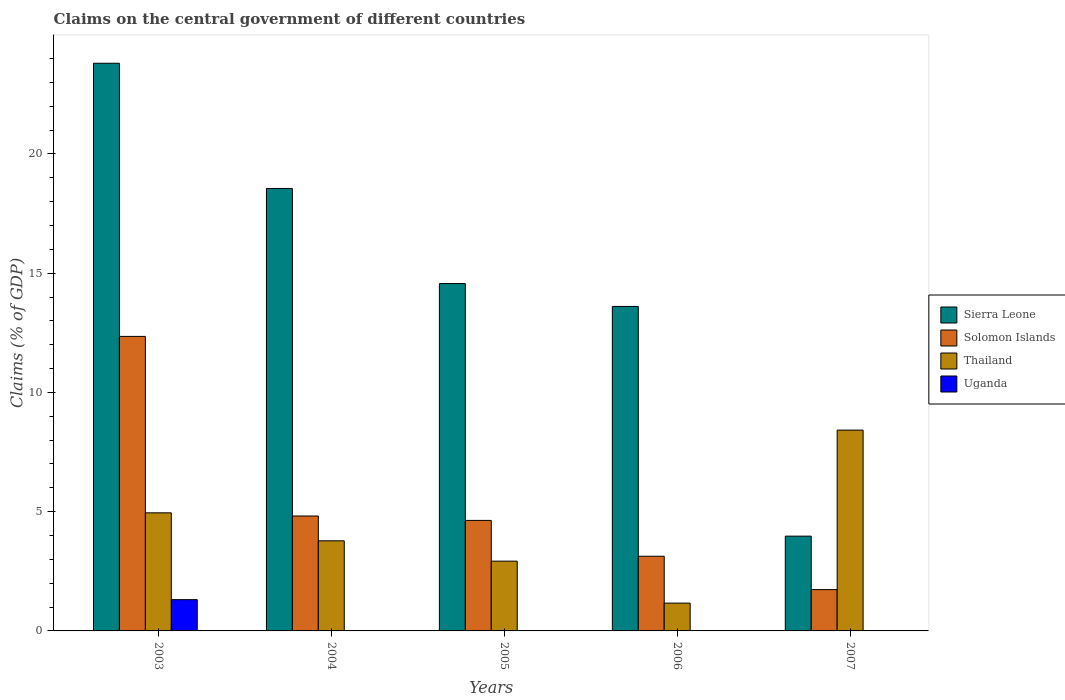Are the number of bars per tick equal to the number of legend labels?
Make the answer very short. No. Are the number of bars on each tick of the X-axis equal?
Offer a very short reply. No. How many bars are there on the 5th tick from the left?
Your answer should be compact. 3. What is the label of the 3rd group of bars from the left?
Your response must be concise. 2005. What is the percentage of GDP claimed on the central government in Sierra Leone in 2006?
Your answer should be very brief. 13.6. Across all years, what is the maximum percentage of GDP claimed on the central government in Uganda?
Offer a very short reply. 1.31. Across all years, what is the minimum percentage of GDP claimed on the central government in Thailand?
Offer a terse response. 1.17. In which year was the percentage of GDP claimed on the central government in Thailand maximum?
Offer a very short reply. 2007. What is the total percentage of GDP claimed on the central government in Uganda in the graph?
Offer a very short reply. 1.31. What is the difference between the percentage of GDP claimed on the central government in Sierra Leone in 2003 and that in 2007?
Your response must be concise. 19.83. What is the difference between the percentage of GDP claimed on the central government in Thailand in 2007 and the percentage of GDP claimed on the central government in Solomon Islands in 2003?
Give a very brief answer. -3.93. What is the average percentage of GDP claimed on the central government in Sierra Leone per year?
Your response must be concise. 14.9. In the year 2006, what is the difference between the percentage of GDP claimed on the central government in Sierra Leone and percentage of GDP claimed on the central government in Solomon Islands?
Give a very brief answer. 10.47. In how many years, is the percentage of GDP claimed on the central government in Solomon Islands greater than 10 %?
Offer a very short reply. 1. What is the ratio of the percentage of GDP claimed on the central government in Solomon Islands in 2003 to that in 2004?
Make the answer very short. 2.56. Is the percentage of GDP claimed on the central government in Thailand in 2003 less than that in 2006?
Offer a very short reply. No. Is the difference between the percentage of GDP claimed on the central government in Sierra Leone in 2005 and 2006 greater than the difference between the percentage of GDP claimed on the central government in Solomon Islands in 2005 and 2006?
Offer a terse response. No. What is the difference between the highest and the second highest percentage of GDP claimed on the central government in Thailand?
Offer a very short reply. 3.47. What is the difference between the highest and the lowest percentage of GDP claimed on the central government in Sierra Leone?
Your answer should be very brief. 19.83. In how many years, is the percentage of GDP claimed on the central government in Uganda greater than the average percentage of GDP claimed on the central government in Uganda taken over all years?
Your answer should be very brief. 1. Is it the case that in every year, the sum of the percentage of GDP claimed on the central government in Uganda and percentage of GDP claimed on the central government in Solomon Islands is greater than the sum of percentage of GDP claimed on the central government in Sierra Leone and percentage of GDP claimed on the central government in Thailand?
Offer a very short reply. No. How many bars are there?
Your response must be concise. 16. How many years are there in the graph?
Give a very brief answer. 5. What is the difference between two consecutive major ticks on the Y-axis?
Keep it short and to the point. 5. Does the graph contain any zero values?
Ensure brevity in your answer.  Yes. What is the title of the graph?
Your answer should be compact. Claims on the central government of different countries. Does "Papua New Guinea" appear as one of the legend labels in the graph?
Your answer should be compact. No. What is the label or title of the X-axis?
Give a very brief answer. Years. What is the label or title of the Y-axis?
Your answer should be compact. Claims (% of GDP). What is the Claims (% of GDP) in Sierra Leone in 2003?
Ensure brevity in your answer.  23.8. What is the Claims (% of GDP) of Solomon Islands in 2003?
Offer a very short reply. 12.35. What is the Claims (% of GDP) of Thailand in 2003?
Your answer should be very brief. 4.95. What is the Claims (% of GDP) of Uganda in 2003?
Keep it short and to the point. 1.31. What is the Claims (% of GDP) in Sierra Leone in 2004?
Provide a short and direct response. 18.55. What is the Claims (% of GDP) in Solomon Islands in 2004?
Provide a short and direct response. 4.82. What is the Claims (% of GDP) in Thailand in 2004?
Provide a short and direct response. 3.78. What is the Claims (% of GDP) in Sierra Leone in 2005?
Keep it short and to the point. 14.56. What is the Claims (% of GDP) of Solomon Islands in 2005?
Offer a terse response. 4.63. What is the Claims (% of GDP) of Thailand in 2005?
Make the answer very short. 2.93. What is the Claims (% of GDP) of Uganda in 2005?
Your response must be concise. 0. What is the Claims (% of GDP) in Sierra Leone in 2006?
Your answer should be very brief. 13.6. What is the Claims (% of GDP) of Solomon Islands in 2006?
Ensure brevity in your answer.  3.13. What is the Claims (% of GDP) of Thailand in 2006?
Your answer should be compact. 1.17. What is the Claims (% of GDP) in Sierra Leone in 2007?
Offer a terse response. 3.97. What is the Claims (% of GDP) in Solomon Islands in 2007?
Your response must be concise. 1.73. What is the Claims (% of GDP) of Thailand in 2007?
Provide a succinct answer. 8.42. Across all years, what is the maximum Claims (% of GDP) in Sierra Leone?
Offer a very short reply. 23.8. Across all years, what is the maximum Claims (% of GDP) of Solomon Islands?
Provide a short and direct response. 12.35. Across all years, what is the maximum Claims (% of GDP) of Thailand?
Your answer should be very brief. 8.42. Across all years, what is the maximum Claims (% of GDP) of Uganda?
Provide a short and direct response. 1.31. Across all years, what is the minimum Claims (% of GDP) of Sierra Leone?
Ensure brevity in your answer.  3.97. Across all years, what is the minimum Claims (% of GDP) in Solomon Islands?
Provide a short and direct response. 1.73. Across all years, what is the minimum Claims (% of GDP) of Thailand?
Offer a terse response. 1.17. Across all years, what is the minimum Claims (% of GDP) in Uganda?
Your answer should be compact. 0. What is the total Claims (% of GDP) of Sierra Leone in the graph?
Ensure brevity in your answer.  74.49. What is the total Claims (% of GDP) of Solomon Islands in the graph?
Your answer should be very brief. 26.66. What is the total Claims (% of GDP) of Thailand in the graph?
Give a very brief answer. 21.24. What is the total Claims (% of GDP) of Uganda in the graph?
Offer a very short reply. 1.31. What is the difference between the Claims (% of GDP) of Sierra Leone in 2003 and that in 2004?
Offer a very short reply. 5.25. What is the difference between the Claims (% of GDP) of Solomon Islands in 2003 and that in 2004?
Provide a short and direct response. 7.53. What is the difference between the Claims (% of GDP) in Thailand in 2003 and that in 2004?
Offer a very short reply. 1.17. What is the difference between the Claims (% of GDP) in Sierra Leone in 2003 and that in 2005?
Keep it short and to the point. 9.24. What is the difference between the Claims (% of GDP) in Solomon Islands in 2003 and that in 2005?
Your answer should be very brief. 7.72. What is the difference between the Claims (% of GDP) of Thailand in 2003 and that in 2005?
Provide a short and direct response. 2.03. What is the difference between the Claims (% of GDP) of Sierra Leone in 2003 and that in 2006?
Ensure brevity in your answer.  10.2. What is the difference between the Claims (% of GDP) in Solomon Islands in 2003 and that in 2006?
Offer a terse response. 9.22. What is the difference between the Claims (% of GDP) of Thailand in 2003 and that in 2006?
Offer a very short reply. 3.79. What is the difference between the Claims (% of GDP) of Sierra Leone in 2003 and that in 2007?
Keep it short and to the point. 19.83. What is the difference between the Claims (% of GDP) in Solomon Islands in 2003 and that in 2007?
Your answer should be compact. 10.62. What is the difference between the Claims (% of GDP) in Thailand in 2003 and that in 2007?
Your answer should be very brief. -3.47. What is the difference between the Claims (% of GDP) of Sierra Leone in 2004 and that in 2005?
Your answer should be very brief. 3.99. What is the difference between the Claims (% of GDP) in Solomon Islands in 2004 and that in 2005?
Provide a succinct answer. 0.18. What is the difference between the Claims (% of GDP) in Thailand in 2004 and that in 2005?
Ensure brevity in your answer.  0.85. What is the difference between the Claims (% of GDP) in Sierra Leone in 2004 and that in 2006?
Make the answer very short. 4.95. What is the difference between the Claims (% of GDP) in Solomon Islands in 2004 and that in 2006?
Offer a terse response. 1.69. What is the difference between the Claims (% of GDP) in Thailand in 2004 and that in 2006?
Your answer should be compact. 2.61. What is the difference between the Claims (% of GDP) of Sierra Leone in 2004 and that in 2007?
Offer a very short reply. 14.58. What is the difference between the Claims (% of GDP) in Solomon Islands in 2004 and that in 2007?
Ensure brevity in your answer.  3.09. What is the difference between the Claims (% of GDP) of Thailand in 2004 and that in 2007?
Make the answer very short. -4.64. What is the difference between the Claims (% of GDP) of Sierra Leone in 2005 and that in 2006?
Your answer should be very brief. 0.96. What is the difference between the Claims (% of GDP) of Solomon Islands in 2005 and that in 2006?
Provide a succinct answer. 1.5. What is the difference between the Claims (% of GDP) of Thailand in 2005 and that in 2006?
Offer a terse response. 1.76. What is the difference between the Claims (% of GDP) in Sierra Leone in 2005 and that in 2007?
Keep it short and to the point. 10.59. What is the difference between the Claims (% of GDP) in Solomon Islands in 2005 and that in 2007?
Your answer should be very brief. 2.9. What is the difference between the Claims (% of GDP) in Thailand in 2005 and that in 2007?
Your response must be concise. -5.49. What is the difference between the Claims (% of GDP) of Sierra Leone in 2006 and that in 2007?
Your response must be concise. 9.63. What is the difference between the Claims (% of GDP) in Solomon Islands in 2006 and that in 2007?
Make the answer very short. 1.4. What is the difference between the Claims (% of GDP) in Thailand in 2006 and that in 2007?
Your answer should be very brief. -7.25. What is the difference between the Claims (% of GDP) in Sierra Leone in 2003 and the Claims (% of GDP) in Solomon Islands in 2004?
Give a very brief answer. 18.98. What is the difference between the Claims (% of GDP) of Sierra Leone in 2003 and the Claims (% of GDP) of Thailand in 2004?
Provide a succinct answer. 20.02. What is the difference between the Claims (% of GDP) of Solomon Islands in 2003 and the Claims (% of GDP) of Thailand in 2004?
Ensure brevity in your answer.  8.57. What is the difference between the Claims (% of GDP) in Sierra Leone in 2003 and the Claims (% of GDP) in Solomon Islands in 2005?
Provide a succinct answer. 19.17. What is the difference between the Claims (% of GDP) in Sierra Leone in 2003 and the Claims (% of GDP) in Thailand in 2005?
Offer a terse response. 20.87. What is the difference between the Claims (% of GDP) of Solomon Islands in 2003 and the Claims (% of GDP) of Thailand in 2005?
Your response must be concise. 9.42. What is the difference between the Claims (% of GDP) of Sierra Leone in 2003 and the Claims (% of GDP) of Solomon Islands in 2006?
Ensure brevity in your answer.  20.67. What is the difference between the Claims (% of GDP) of Sierra Leone in 2003 and the Claims (% of GDP) of Thailand in 2006?
Your response must be concise. 22.63. What is the difference between the Claims (% of GDP) of Solomon Islands in 2003 and the Claims (% of GDP) of Thailand in 2006?
Give a very brief answer. 11.18. What is the difference between the Claims (% of GDP) of Sierra Leone in 2003 and the Claims (% of GDP) of Solomon Islands in 2007?
Provide a short and direct response. 22.07. What is the difference between the Claims (% of GDP) in Sierra Leone in 2003 and the Claims (% of GDP) in Thailand in 2007?
Your response must be concise. 15.38. What is the difference between the Claims (% of GDP) in Solomon Islands in 2003 and the Claims (% of GDP) in Thailand in 2007?
Offer a terse response. 3.93. What is the difference between the Claims (% of GDP) in Sierra Leone in 2004 and the Claims (% of GDP) in Solomon Islands in 2005?
Provide a succinct answer. 13.92. What is the difference between the Claims (% of GDP) of Sierra Leone in 2004 and the Claims (% of GDP) of Thailand in 2005?
Ensure brevity in your answer.  15.63. What is the difference between the Claims (% of GDP) of Solomon Islands in 2004 and the Claims (% of GDP) of Thailand in 2005?
Your response must be concise. 1.89. What is the difference between the Claims (% of GDP) in Sierra Leone in 2004 and the Claims (% of GDP) in Solomon Islands in 2006?
Keep it short and to the point. 15.42. What is the difference between the Claims (% of GDP) in Sierra Leone in 2004 and the Claims (% of GDP) in Thailand in 2006?
Offer a terse response. 17.39. What is the difference between the Claims (% of GDP) in Solomon Islands in 2004 and the Claims (% of GDP) in Thailand in 2006?
Your response must be concise. 3.65. What is the difference between the Claims (% of GDP) of Sierra Leone in 2004 and the Claims (% of GDP) of Solomon Islands in 2007?
Offer a very short reply. 16.82. What is the difference between the Claims (% of GDP) of Sierra Leone in 2004 and the Claims (% of GDP) of Thailand in 2007?
Keep it short and to the point. 10.13. What is the difference between the Claims (% of GDP) in Solomon Islands in 2004 and the Claims (% of GDP) in Thailand in 2007?
Your answer should be compact. -3.6. What is the difference between the Claims (% of GDP) of Sierra Leone in 2005 and the Claims (% of GDP) of Solomon Islands in 2006?
Your answer should be compact. 11.43. What is the difference between the Claims (% of GDP) of Sierra Leone in 2005 and the Claims (% of GDP) of Thailand in 2006?
Your answer should be compact. 13.4. What is the difference between the Claims (% of GDP) in Solomon Islands in 2005 and the Claims (% of GDP) in Thailand in 2006?
Your response must be concise. 3.47. What is the difference between the Claims (% of GDP) of Sierra Leone in 2005 and the Claims (% of GDP) of Solomon Islands in 2007?
Provide a short and direct response. 12.83. What is the difference between the Claims (% of GDP) of Sierra Leone in 2005 and the Claims (% of GDP) of Thailand in 2007?
Offer a very short reply. 6.14. What is the difference between the Claims (% of GDP) in Solomon Islands in 2005 and the Claims (% of GDP) in Thailand in 2007?
Keep it short and to the point. -3.79. What is the difference between the Claims (% of GDP) in Sierra Leone in 2006 and the Claims (% of GDP) in Solomon Islands in 2007?
Make the answer very short. 11.87. What is the difference between the Claims (% of GDP) of Sierra Leone in 2006 and the Claims (% of GDP) of Thailand in 2007?
Provide a succinct answer. 5.18. What is the difference between the Claims (% of GDP) in Solomon Islands in 2006 and the Claims (% of GDP) in Thailand in 2007?
Give a very brief answer. -5.29. What is the average Claims (% of GDP) of Sierra Leone per year?
Ensure brevity in your answer.  14.9. What is the average Claims (% of GDP) of Solomon Islands per year?
Offer a terse response. 5.33. What is the average Claims (% of GDP) in Thailand per year?
Keep it short and to the point. 4.25. What is the average Claims (% of GDP) in Uganda per year?
Make the answer very short. 0.26. In the year 2003, what is the difference between the Claims (% of GDP) in Sierra Leone and Claims (% of GDP) in Solomon Islands?
Keep it short and to the point. 11.45. In the year 2003, what is the difference between the Claims (% of GDP) in Sierra Leone and Claims (% of GDP) in Thailand?
Give a very brief answer. 18.85. In the year 2003, what is the difference between the Claims (% of GDP) of Sierra Leone and Claims (% of GDP) of Uganda?
Offer a terse response. 22.49. In the year 2003, what is the difference between the Claims (% of GDP) of Solomon Islands and Claims (% of GDP) of Thailand?
Ensure brevity in your answer.  7.4. In the year 2003, what is the difference between the Claims (% of GDP) of Solomon Islands and Claims (% of GDP) of Uganda?
Your answer should be very brief. 11.04. In the year 2003, what is the difference between the Claims (% of GDP) of Thailand and Claims (% of GDP) of Uganda?
Give a very brief answer. 3.64. In the year 2004, what is the difference between the Claims (% of GDP) in Sierra Leone and Claims (% of GDP) in Solomon Islands?
Make the answer very short. 13.73. In the year 2004, what is the difference between the Claims (% of GDP) of Sierra Leone and Claims (% of GDP) of Thailand?
Provide a short and direct response. 14.77. In the year 2004, what is the difference between the Claims (% of GDP) in Solomon Islands and Claims (% of GDP) in Thailand?
Give a very brief answer. 1.04. In the year 2005, what is the difference between the Claims (% of GDP) in Sierra Leone and Claims (% of GDP) in Solomon Islands?
Give a very brief answer. 9.93. In the year 2005, what is the difference between the Claims (% of GDP) of Sierra Leone and Claims (% of GDP) of Thailand?
Ensure brevity in your answer.  11.64. In the year 2005, what is the difference between the Claims (% of GDP) in Solomon Islands and Claims (% of GDP) in Thailand?
Keep it short and to the point. 1.71. In the year 2006, what is the difference between the Claims (% of GDP) in Sierra Leone and Claims (% of GDP) in Solomon Islands?
Keep it short and to the point. 10.47. In the year 2006, what is the difference between the Claims (% of GDP) of Sierra Leone and Claims (% of GDP) of Thailand?
Keep it short and to the point. 12.44. In the year 2006, what is the difference between the Claims (% of GDP) in Solomon Islands and Claims (% of GDP) in Thailand?
Ensure brevity in your answer.  1.97. In the year 2007, what is the difference between the Claims (% of GDP) of Sierra Leone and Claims (% of GDP) of Solomon Islands?
Make the answer very short. 2.24. In the year 2007, what is the difference between the Claims (% of GDP) in Sierra Leone and Claims (% of GDP) in Thailand?
Keep it short and to the point. -4.45. In the year 2007, what is the difference between the Claims (% of GDP) in Solomon Islands and Claims (% of GDP) in Thailand?
Your answer should be compact. -6.69. What is the ratio of the Claims (% of GDP) of Sierra Leone in 2003 to that in 2004?
Make the answer very short. 1.28. What is the ratio of the Claims (% of GDP) in Solomon Islands in 2003 to that in 2004?
Your answer should be very brief. 2.56. What is the ratio of the Claims (% of GDP) in Thailand in 2003 to that in 2004?
Your response must be concise. 1.31. What is the ratio of the Claims (% of GDP) of Sierra Leone in 2003 to that in 2005?
Your answer should be compact. 1.63. What is the ratio of the Claims (% of GDP) of Solomon Islands in 2003 to that in 2005?
Keep it short and to the point. 2.67. What is the ratio of the Claims (% of GDP) of Thailand in 2003 to that in 2005?
Offer a very short reply. 1.69. What is the ratio of the Claims (% of GDP) of Sierra Leone in 2003 to that in 2006?
Ensure brevity in your answer.  1.75. What is the ratio of the Claims (% of GDP) in Solomon Islands in 2003 to that in 2006?
Ensure brevity in your answer.  3.94. What is the ratio of the Claims (% of GDP) in Thailand in 2003 to that in 2006?
Offer a very short reply. 4.25. What is the ratio of the Claims (% of GDP) of Sierra Leone in 2003 to that in 2007?
Offer a terse response. 5.99. What is the ratio of the Claims (% of GDP) of Solomon Islands in 2003 to that in 2007?
Make the answer very short. 7.13. What is the ratio of the Claims (% of GDP) of Thailand in 2003 to that in 2007?
Offer a terse response. 0.59. What is the ratio of the Claims (% of GDP) of Sierra Leone in 2004 to that in 2005?
Offer a terse response. 1.27. What is the ratio of the Claims (% of GDP) of Solomon Islands in 2004 to that in 2005?
Your answer should be compact. 1.04. What is the ratio of the Claims (% of GDP) of Thailand in 2004 to that in 2005?
Provide a succinct answer. 1.29. What is the ratio of the Claims (% of GDP) of Sierra Leone in 2004 to that in 2006?
Ensure brevity in your answer.  1.36. What is the ratio of the Claims (% of GDP) in Solomon Islands in 2004 to that in 2006?
Make the answer very short. 1.54. What is the ratio of the Claims (% of GDP) in Thailand in 2004 to that in 2006?
Your answer should be very brief. 3.24. What is the ratio of the Claims (% of GDP) of Sierra Leone in 2004 to that in 2007?
Provide a succinct answer. 4.67. What is the ratio of the Claims (% of GDP) of Solomon Islands in 2004 to that in 2007?
Offer a terse response. 2.78. What is the ratio of the Claims (% of GDP) in Thailand in 2004 to that in 2007?
Keep it short and to the point. 0.45. What is the ratio of the Claims (% of GDP) in Sierra Leone in 2005 to that in 2006?
Provide a short and direct response. 1.07. What is the ratio of the Claims (% of GDP) in Solomon Islands in 2005 to that in 2006?
Provide a short and direct response. 1.48. What is the ratio of the Claims (% of GDP) in Thailand in 2005 to that in 2006?
Keep it short and to the point. 2.51. What is the ratio of the Claims (% of GDP) of Sierra Leone in 2005 to that in 2007?
Give a very brief answer. 3.67. What is the ratio of the Claims (% of GDP) of Solomon Islands in 2005 to that in 2007?
Offer a very short reply. 2.67. What is the ratio of the Claims (% of GDP) of Thailand in 2005 to that in 2007?
Offer a very short reply. 0.35. What is the ratio of the Claims (% of GDP) of Sierra Leone in 2006 to that in 2007?
Give a very brief answer. 3.42. What is the ratio of the Claims (% of GDP) in Solomon Islands in 2006 to that in 2007?
Offer a very short reply. 1.81. What is the ratio of the Claims (% of GDP) of Thailand in 2006 to that in 2007?
Your answer should be compact. 0.14. What is the difference between the highest and the second highest Claims (% of GDP) of Sierra Leone?
Provide a succinct answer. 5.25. What is the difference between the highest and the second highest Claims (% of GDP) of Solomon Islands?
Provide a succinct answer. 7.53. What is the difference between the highest and the second highest Claims (% of GDP) in Thailand?
Provide a short and direct response. 3.47. What is the difference between the highest and the lowest Claims (% of GDP) of Sierra Leone?
Your answer should be compact. 19.83. What is the difference between the highest and the lowest Claims (% of GDP) in Solomon Islands?
Your response must be concise. 10.62. What is the difference between the highest and the lowest Claims (% of GDP) in Thailand?
Ensure brevity in your answer.  7.25. What is the difference between the highest and the lowest Claims (% of GDP) of Uganda?
Your answer should be very brief. 1.31. 